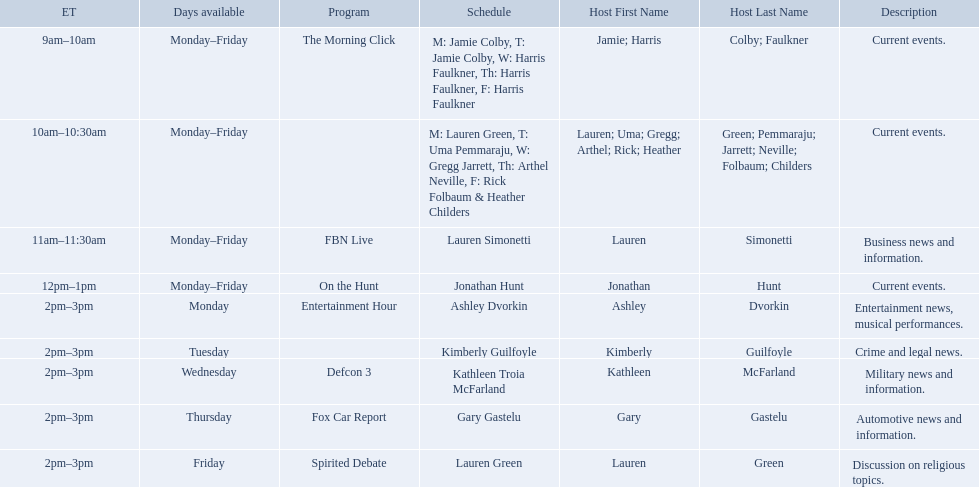Who are all of the hosts? Jamie Colby (M,T), Harris Faulkner (W–F), Lauren Green (M), Uma Pemmaraju (T), Gregg Jarrett (W), Arthel Neville (F), Rick Folbaum (F), Heather Childers, Lauren Simonetti, Jonathan Hunt, Ashley Dvorkin, Kimberly Guilfoyle, Kathleen Troia McFarland, Gary Gastelu, Lauren Green. Which hosts have shows on fridays? Jamie Colby (M,T), Harris Faulkner (W–F), Lauren Green (M), Uma Pemmaraju (T), Gregg Jarrett (W), Arthel Neville (F), Rick Folbaum (F), Heather Childers, Lauren Simonetti, Jonathan Hunt, Lauren Green. Of those, which host's show airs at 2pm? Lauren Green. Which programs broadcast by fox news channel hosts are listed? Jamie Colby (M,T), Harris Faulkner (W–F), Lauren Green (M), Uma Pemmaraju (T), Gregg Jarrett (W), Arthel Neville (F), Rick Folbaum (F), Heather Childers, Lauren Simonetti, Jonathan Hunt, Ashley Dvorkin, Kimberly Guilfoyle, Kathleen Troia McFarland, Gary Gastelu, Lauren Green. Of those, who have shows on friday? Jamie Colby (M,T), Harris Faulkner (W–F), Lauren Green (M), Uma Pemmaraju (T), Gregg Jarrett (W), Arthel Neville (F), Rick Folbaum (F), Heather Childers, Lauren Simonetti, Jonathan Hunt, Lauren Green. Of those, whose is at 2 pm? Lauren Green. 